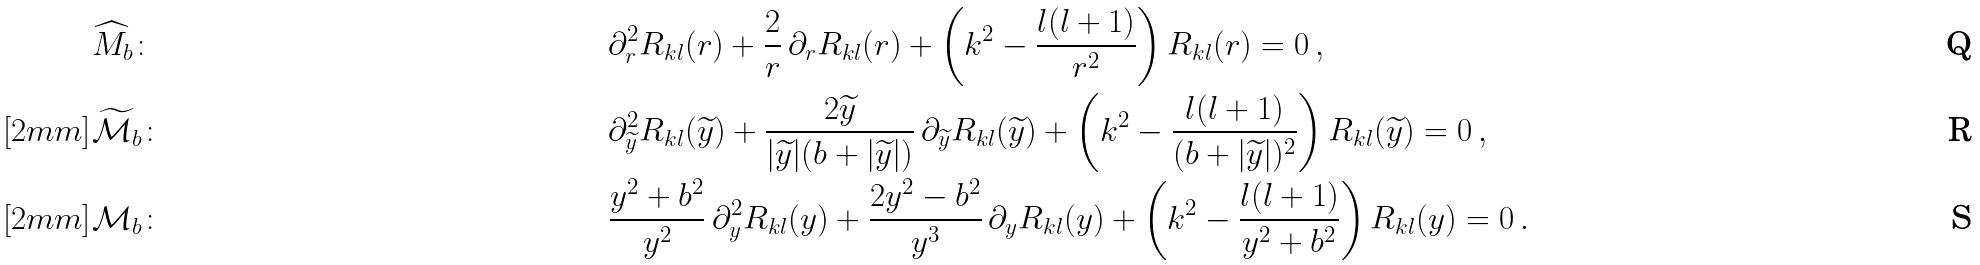Convert formula to latex. <formula><loc_0><loc_0><loc_500><loc_500>& \widehat { M } _ { b } \colon & & \partial ^ { 2 } _ { r } R _ { k l } ( r ) + \frac { 2 } { r } \, \partial _ { r } R _ { k l } ( r ) + \left ( k ^ { 2 } - \frac { l ( l + 1 ) } { r ^ { 2 } } \right ) R _ { k l } ( r ) = 0 \, , \\ [ 2 m m ] & \widetilde { \mathcal { M } } _ { b } \colon & & \partial ^ { 2 } _ { \widetilde { y } } R _ { k l } ( \widetilde { y } ) + \frac { 2 \widetilde { y } } { | \widetilde { y } | ( b + | \widetilde { y } | ) } \, \partial _ { \widetilde { y } } R _ { k l } ( \widetilde { y } ) + \left ( k ^ { 2 } - \frac { l ( l + 1 ) } { ( b + | \widetilde { y } | ) ^ { 2 } } \right ) R _ { k l } ( \widetilde { y } ) = 0 \, , \\ [ 2 m m ] & \mathcal { M } _ { b } \colon & & \frac { y ^ { 2 } + b ^ { 2 } } { y ^ { 2 } } \, \partial ^ { 2 } _ { y } R _ { k l } ( y ) + \frac { 2 y ^ { 2 } - b ^ { 2 } } { y ^ { 3 } } \, \partial _ { y } R _ { k l } ( y ) + \left ( k ^ { 2 } - \frac { l ( l + 1 ) } { y ^ { 2 } + b ^ { 2 } } \right ) R _ { k l } ( y ) = 0 \, .</formula> 